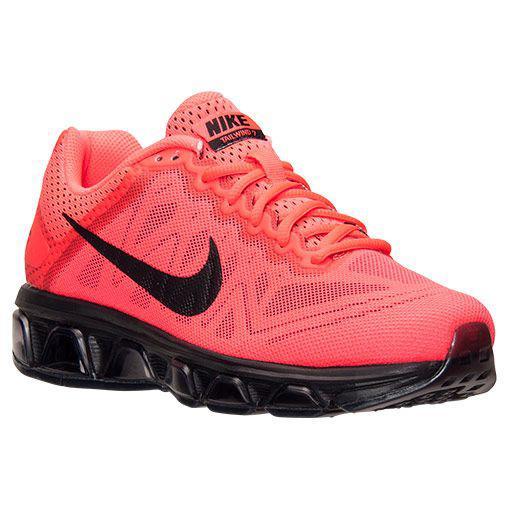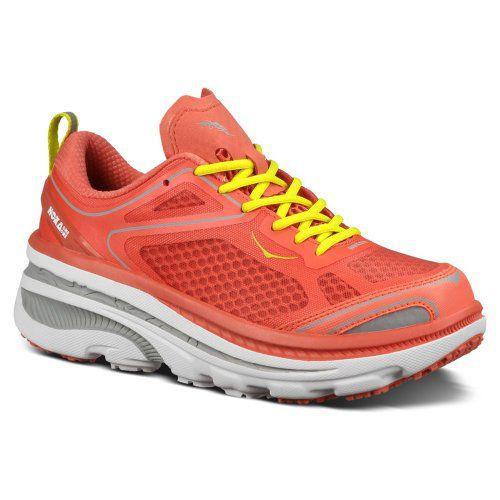The first image is the image on the left, the second image is the image on the right. Considering the images on both sides, is "There is a red shoe with solid black laces." valid? Answer yes or no. No. 